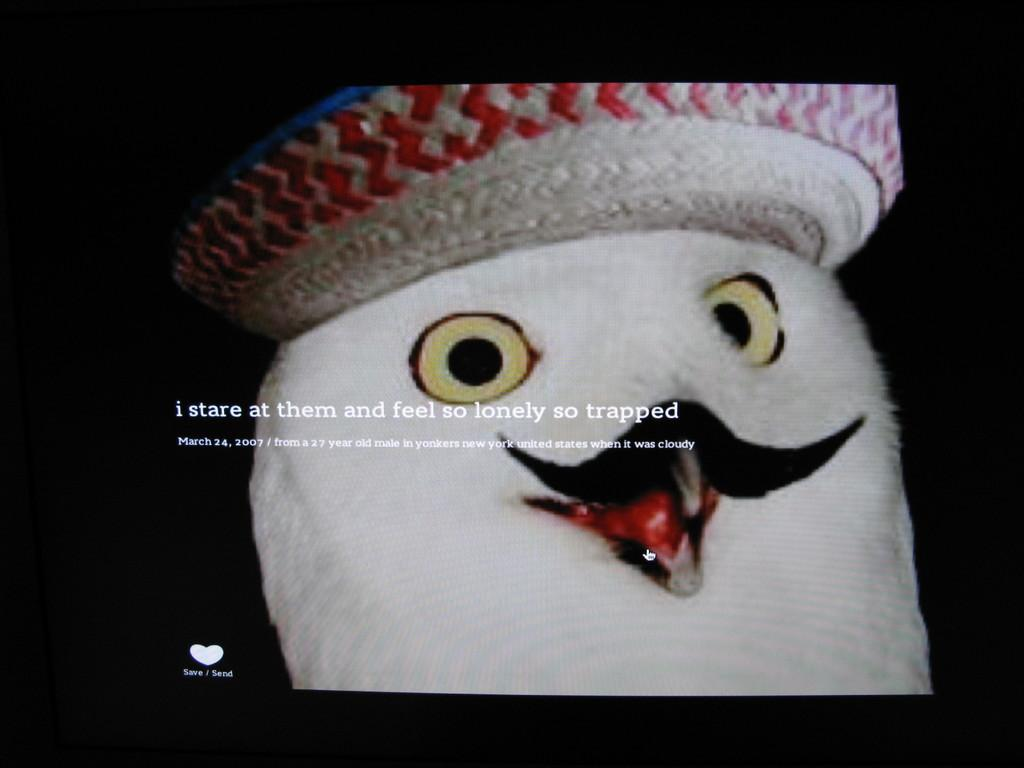What is the main subject of the image? The main subject of the image is a screenshot of a screen. What can be seen on the screen in the image? There is a toy in the image. Is there any text visible in the image? Yes, there is text in the image. What type of lunch is being served in the image? There is no lunch present in the image; it is a screenshot of a screen with a toy and text. Can you tell me where the store is located in the image? There is no store present in the image; it is a screenshot of a screen with a toy and text. 